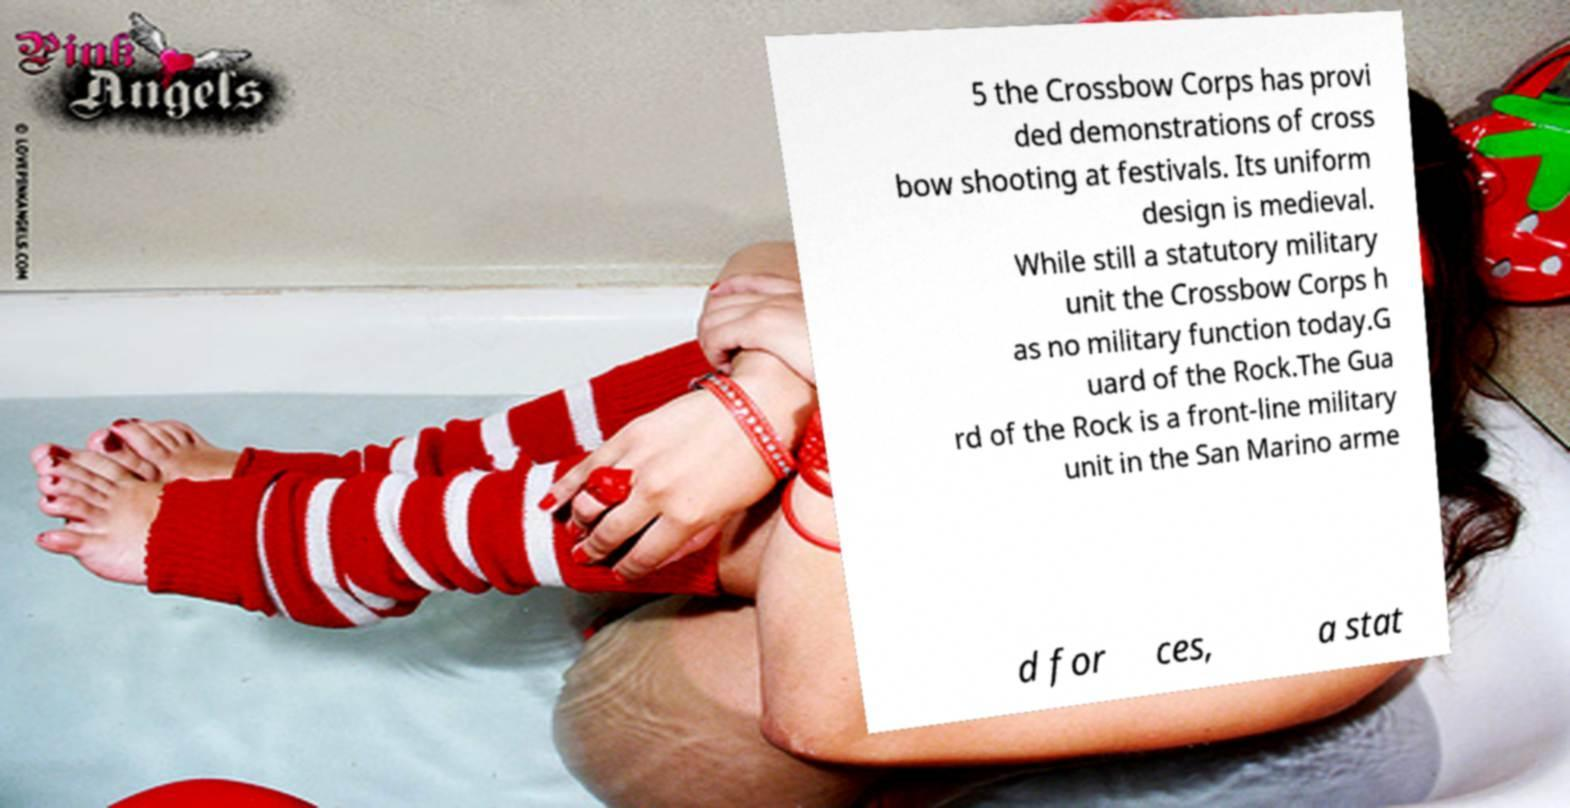For documentation purposes, I need the text within this image transcribed. Could you provide that? 5 the Crossbow Corps has provi ded demonstrations of cross bow shooting at festivals. Its uniform design is medieval. While still a statutory military unit the Crossbow Corps h as no military function today.G uard of the Rock.The Gua rd of the Rock is a front-line military unit in the San Marino arme d for ces, a stat 